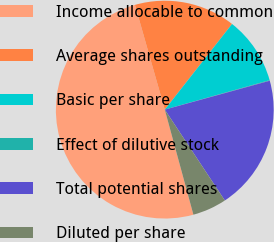<chart> <loc_0><loc_0><loc_500><loc_500><pie_chart><fcel>Income allocable to common<fcel>Average shares outstanding<fcel>Basic per share<fcel>Effect of dilutive stock<fcel>Total potential shares<fcel>Diluted per share<nl><fcel>49.82%<fcel>15.01%<fcel>10.04%<fcel>0.09%<fcel>19.98%<fcel>5.06%<nl></chart> 